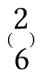<formula> <loc_0><loc_0><loc_500><loc_500>( \begin{matrix} 2 \\ 6 \end{matrix} )</formula> 